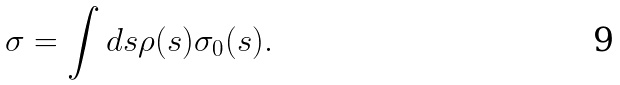Convert formula to latex. <formula><loc_0><loc_0><loc_500><loc_500>\sigma = \int d s \rho ( s ) \sigma _ { 0 } ( s ) .</formula> 